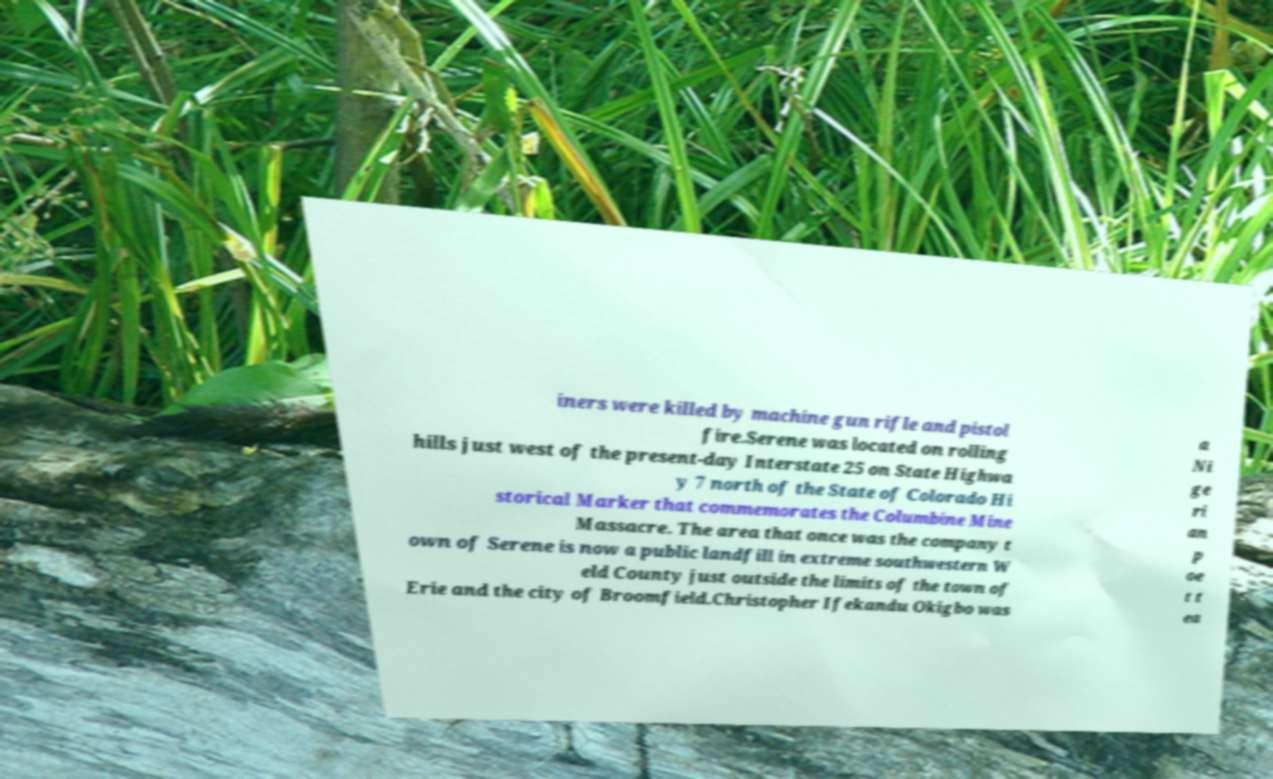Please read and relay the text visible in this image. What does it say? iners were killed by machine gun rifle and pistol fire.Serene was located on rolling hills just west of the present-day Interstate 25 on State Highwa y 7 north of the State of Colorado Hi storical Marker that commemorates the Columbine Mine Massacre. The area that once was the company t own of Serene is now a public landfill in extreme southwestern W eld County just outside the limits of the town of Erie and the city of Broomfield.Christopher Ifekandu Okigbo was a Ni ge ri an p oe t t ea 